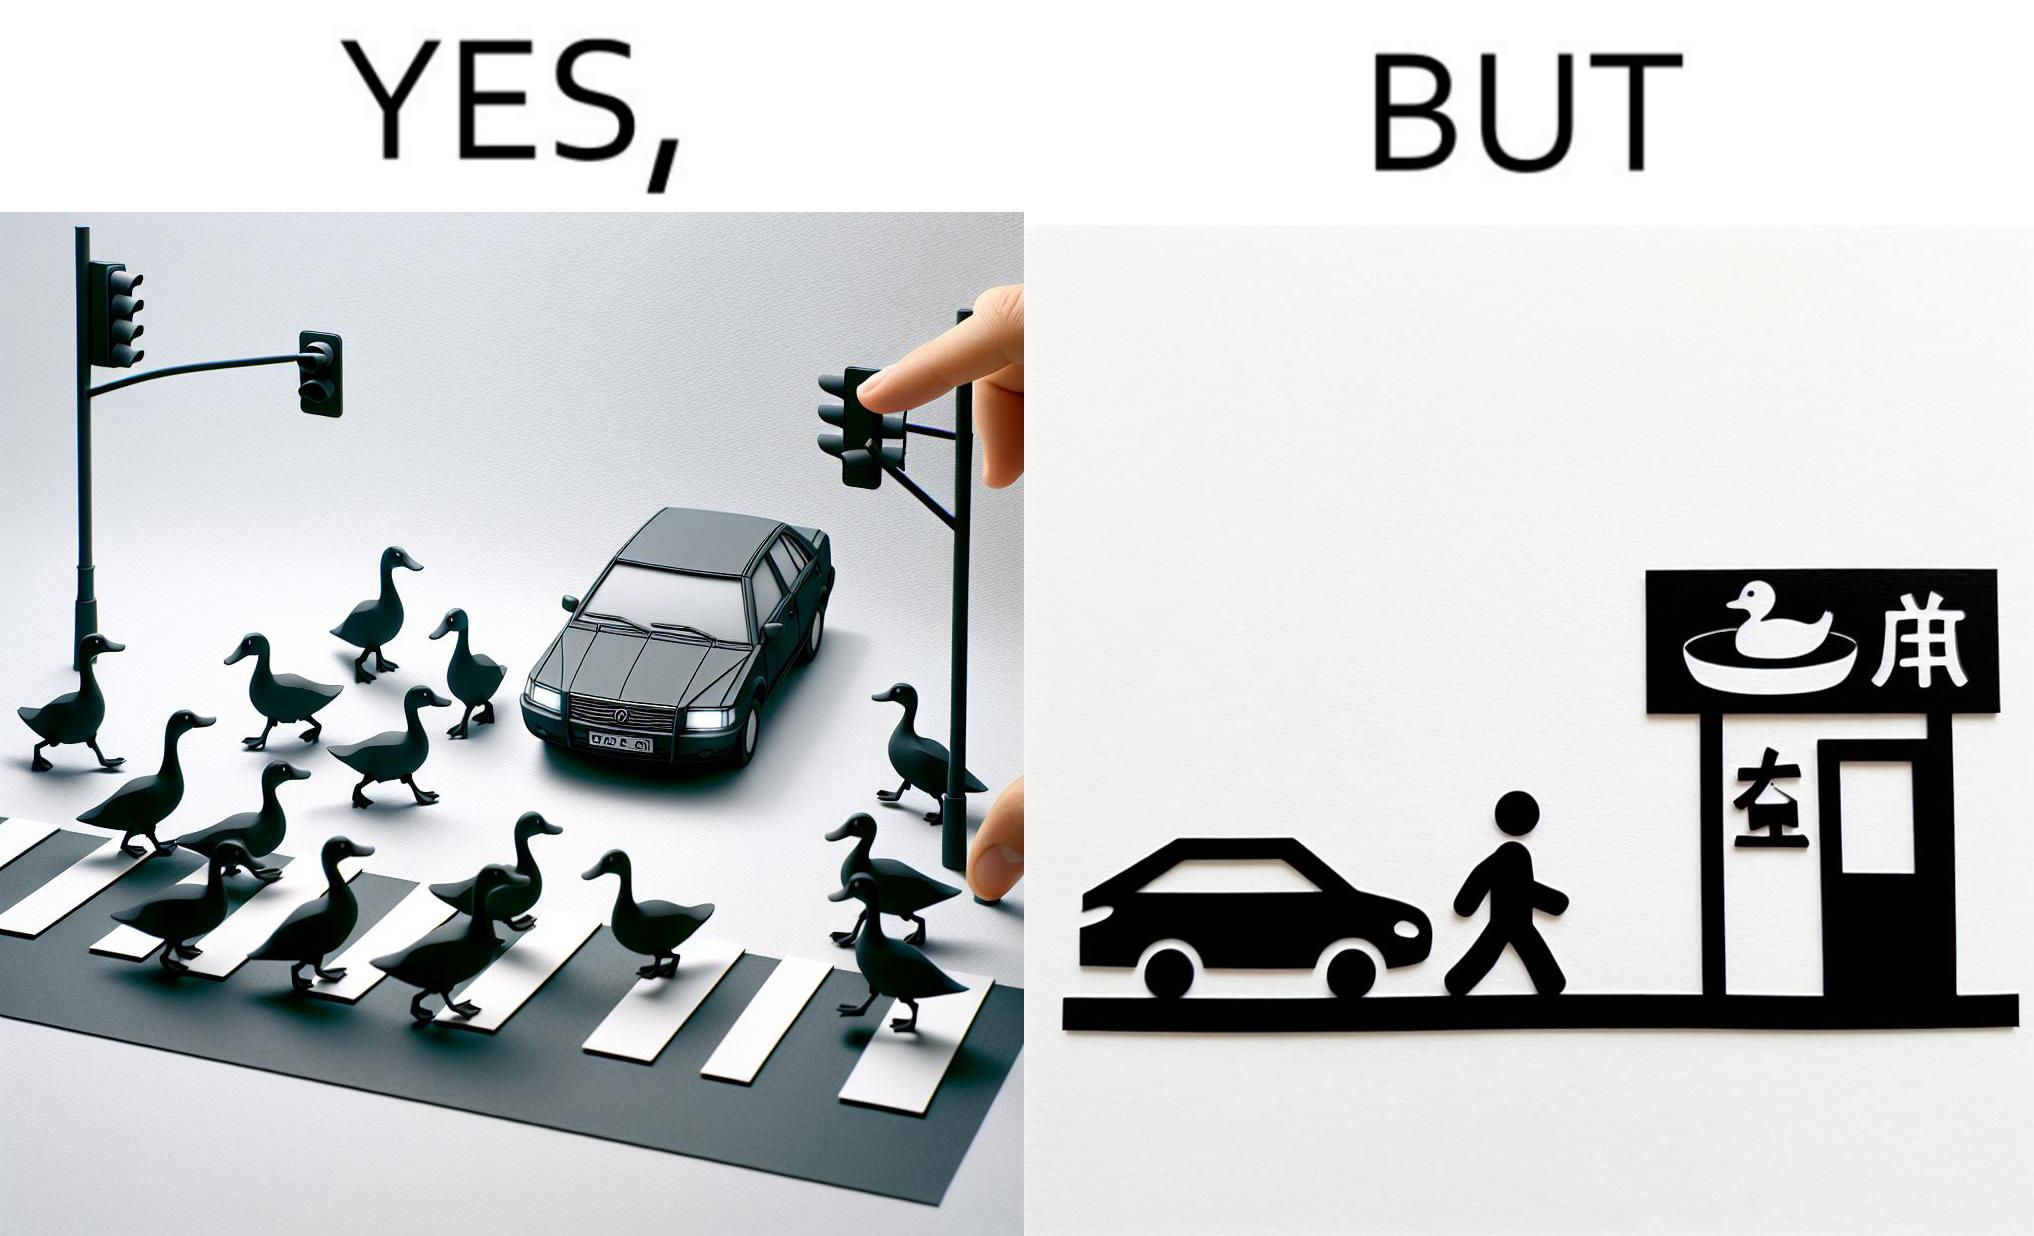Is this a satirical image? Yes, this image is satirical. 